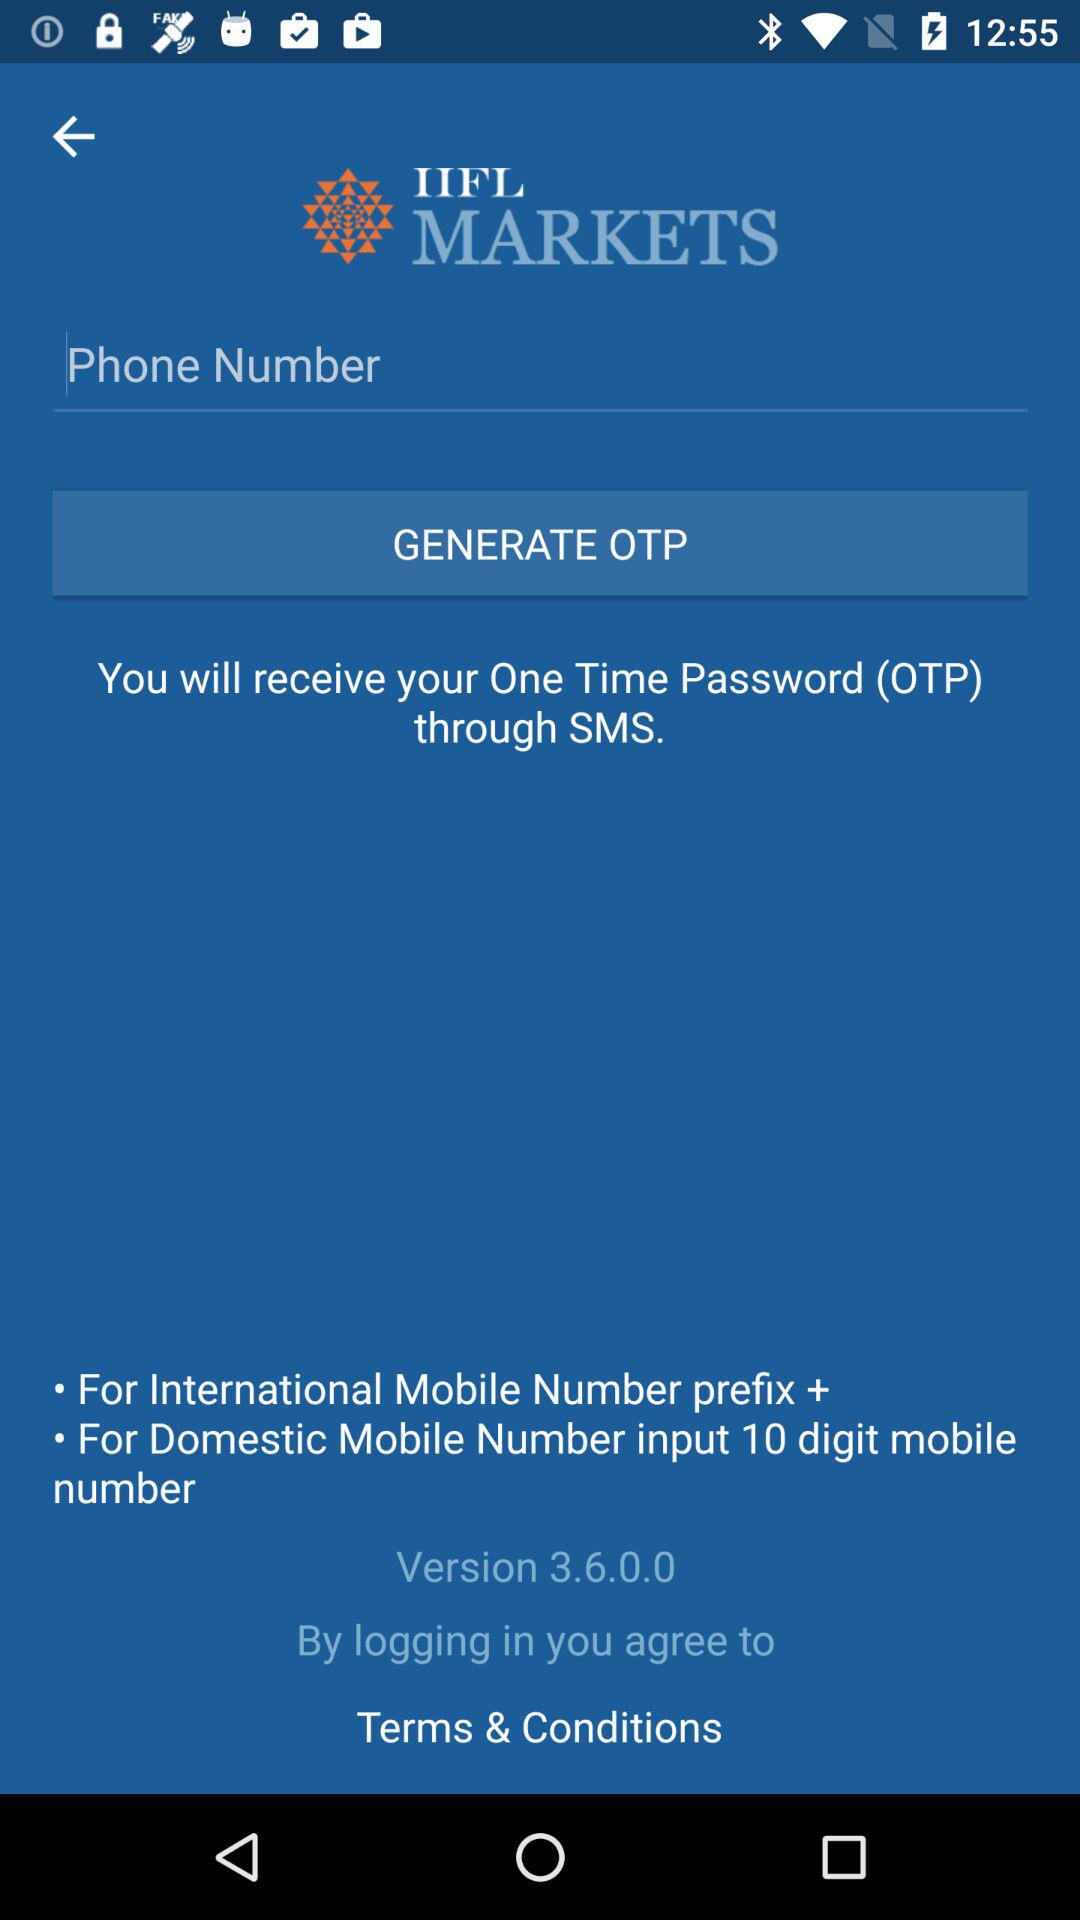What is the version of the application? The version of the application is 3.6.0.0. 